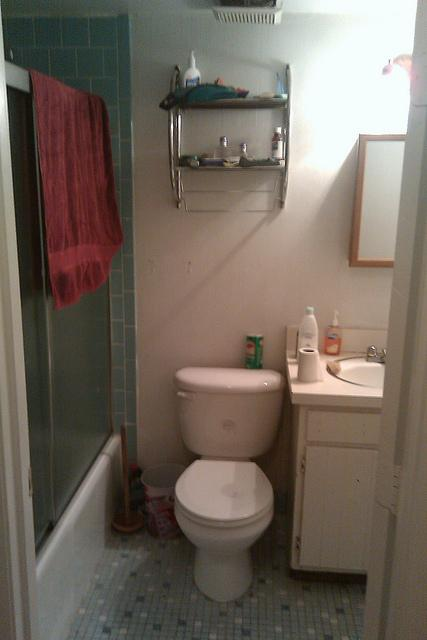What is in the container on the toilet tank?

Choices:
A) baby powder
B) toothpaste
C) bubble bath
D) cleanser cleanser 